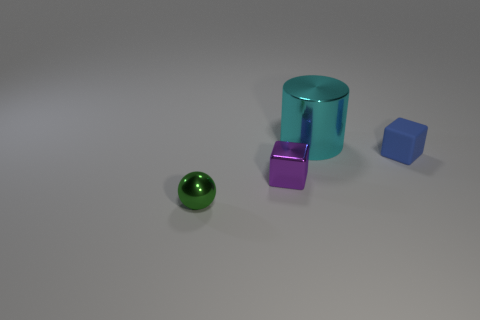Is there any other thing that has the same size as the metal cylinder?
Offer a very short reply. No. Is there any other thing that has the same material as the small blue thing?
Give a very brief answer. No. Are there more tiny things on the right side of the sphere than small metal objects that are right of the rubber cube?
Provide a short and direct response. Yes. Is the small blue cube made of the same material as the object in front of the purple thing?
Give a very brief answer. No. Is there any other thing that has the same shape as the green object?
Your response must be concise. No. There is a shiny object that is on the right side of the small metal ball and left of the cyan object; what color is it?
Give a very brief answer. Purple. The small metal thing that is on the right side of the green metallic thing has what shape?
Keep it short and to the point. Cube. There is a thing that is behind the small block that is to the right of the small metallic object right of the small green shiny sphere; what is its size?
Ensure brevity in your answer.  Large. There is a small block to the right of the cyan cylinder; how many tiny things are in front of it?
Offer a terse response. 2. There is a object that is both behind the small green sphere and on the left side of the large metal cylinder; what is its size?
Keep it short and to the point. Small. 